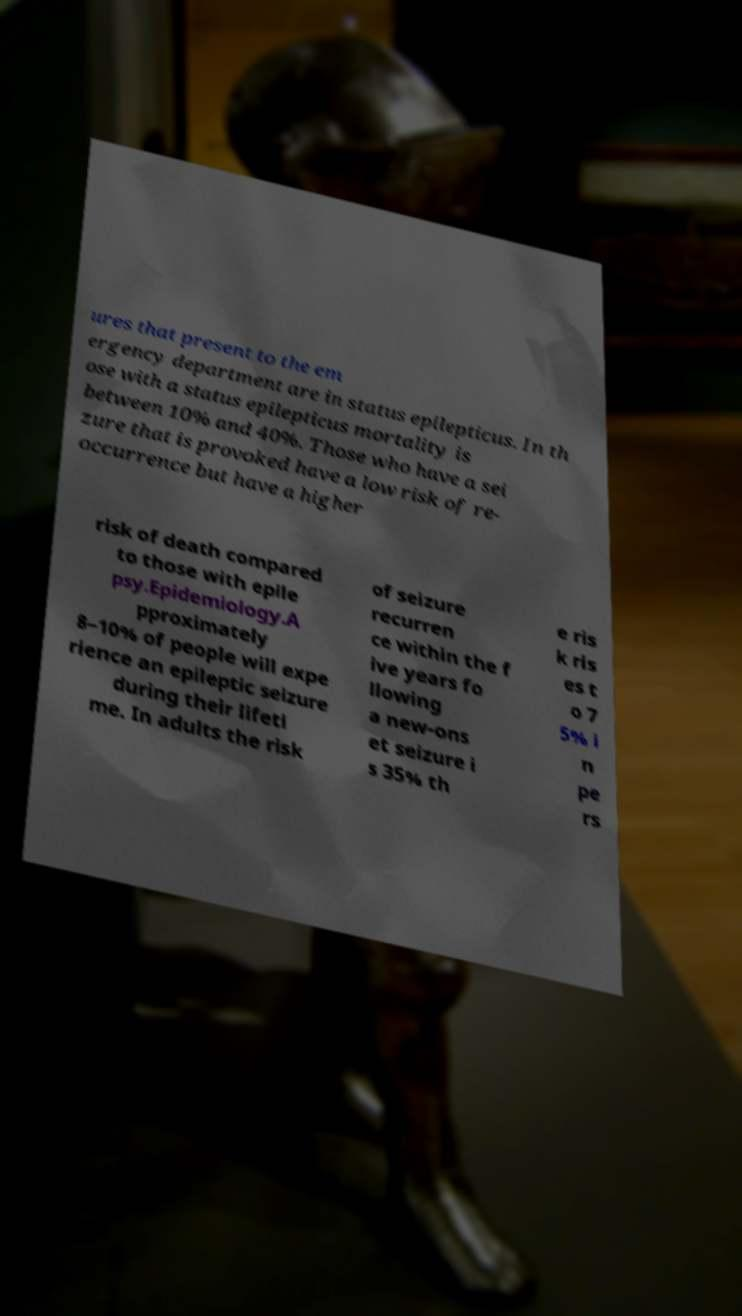Please identify and transcribe the text found in this image. ures that present to the em ergency department are in status epilepticus. In th ose with a status epilepticus mortality is between 10% and 40%. Those who have a sei zure that is provoked have a low risk of re- occurrence but have a higher risk of death compared to those with epile psy.Epidemiology.A pproximately 8–10% of people will expe rience an epileptic seizure during their lifeti me. In adults the risk of seizure recurren ce within the f ive years fo llowing a new-ons et seizure i s 35% th e ris k ris es t o 7 5% i n pe rs 